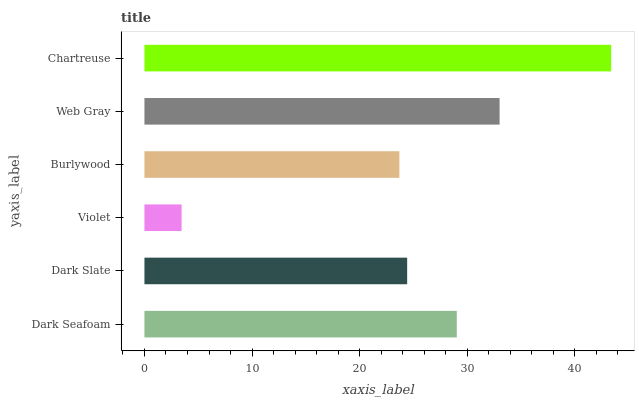Is Violet the minimum?
Answer yes or no. Yes. Is Chartreuse the maximum?
Answer yes or no. Yes. Is Dark Slate the minimum?
Answer yes or no. No. Is Dark Slate the maximum?
Answer yes or no. No. Is Dark Seafoam greater than Dark Slate?
Answer yes or no. Yes. Is Dark Slate less than Dark Seafoam?
Answer yes or no. Yes. Is Dark Slate greater than Dark Seafoam?
Answer yes or no. No. Is Dark Seafoam less than Dark Slate?
Answer yes or no. No. Is Dark Seafoam the high median?
Answer yes or no. Yes. Is Dark Slate the low median?
Answer yes or no. Yes. Is Dark Slate the high median?
Answer yes or no. No. Is Violet the low median?
Answer yes or no. No. 